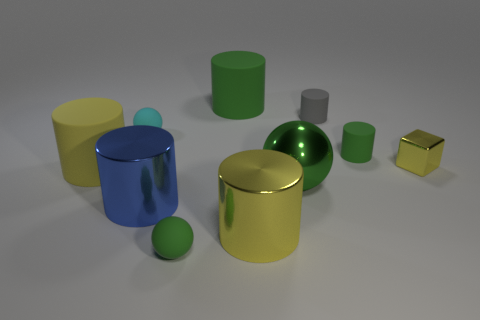Subtract all small cylinders. How many cylinders are left? 4 Subtract all gray cylinders. How many cylinders are left? 5 Subtract 3 cylinders. How many cylinders are left? 3 Subtract all gray cylinders. Subtract all cyan balls. How many cylinders are left? 5 Subtract all blocks. How many objects are left? 9 Subtract all large gray rubber balls. Subtract all small spheres. How many objects are left? 8 Add 3 small matte cylinders. How many small matte cylinders are left? 5 Add 2 small cubes. How many small cubes exist? 3 Subtract 0 brown cubes. How many objects are left? 10 